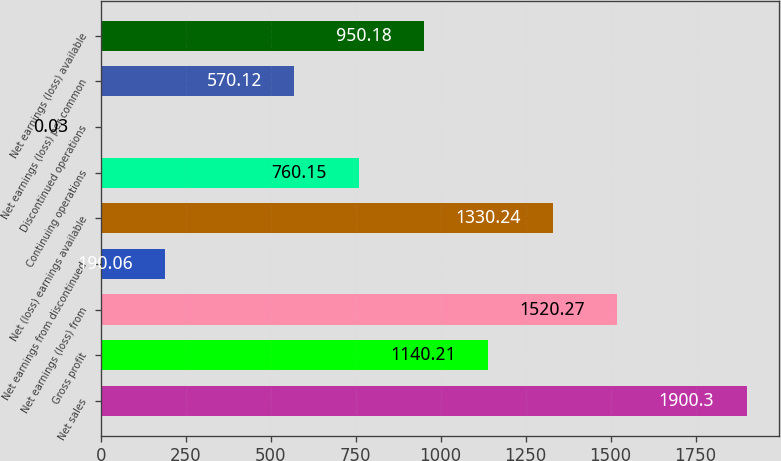Convert chart. <chart><loc_0><loc_0><loc_500><loc_500><bar_chart><fcel>Net sales<fcel>Gross profit<fcel>Net earnings (loss) from<fcel>Net earnings from discontinued<fcel>Net (loss) earnings available<fcel>Continuing operations<fcel>Discontinued operations<fcel>Net earnings (loss) per common<fcel>Net earnings (loss) available<nl><fcel>1900.3<fcel>1140.21<fcel>1520.27<fcel>190.06<fcel>1330.24<fcel>760.15<fcel>0.03<fcel>570.12<fcel>950.18<nl></chart> 